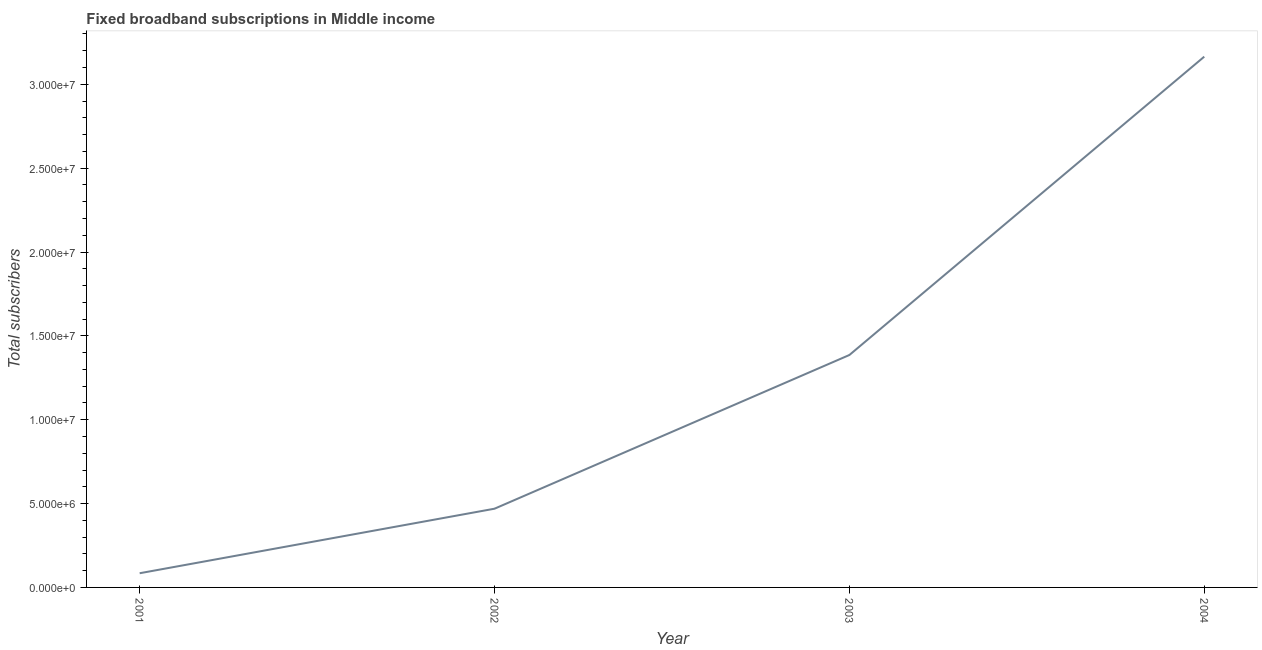What is the total number of fixed broadband subscriptions in 2001?
Offer a terse response. 8.47e+05. Across all years, what is the maximum total number of fixed broadband subscriptions?
Ensure brevity in your answer.  3.16e+07. Across all years, what is the minimum total number of fixed broadband subscriptions?
Keep it short and to the point. 8.47e+05. In which year was the total number of fixed broadband subscriptions maximum?
Provide a short and direct response. 2004. In which year was the total number of fixed broadband subscriptions minimum?
Your answer should be compact. 2001. What is the sum of the total number of fixed broadband subscriptions?
Your answer should be compact. 5.10e+07. What is the difference between the total number of fixed broadband subscriptions in 2001 and 2004?
Make the answer very short. -3.08e+07. What is the average total number of fixed broadband subscriptions per year?
Your response must be concise. 1.28e+07. What is the median total number of fixed broadband subscriptions?
Provide a succinct answer. 9.28e+06. In how many years, is the total number of fixed broadband subscriptions greater than 22000000 ?
Offer a terse response. 1. Do a majority of the years between 2001 and 2002 (inclusive) have total number of fixed broadband subscriptions greater than 25000000 ?
Your response must be concise. No. What is the ratio of the total number of fixed broadband subscriptions in 2001 to that in 2003?
Keep it short and to the point. 0.06. Is the total number of fixed broadband subscriptions in 2001 less than that in 2004?
Give a very brief answer. Yes. What is the difference between the highest and the second highest total number of fixed broadband subscriptions?
Offer a terse response. 1.78e+07. Is the sum of the total number of fixed broadband subscriptions in 2001 and 2004 greater than the maximum total number of fixed broadband subscriptions across all years?
Provide a short and direct response. Yes. What is the difference between the highest and the lowest total number of fixed broadband subscriptions?
Provide a short and direct response. 3.08e+07. How many lines are there?
Make the answer very short. 1. Are the values on the major ticks of Y-axis written in scientific E-notation?
Offer a terse response. Yes. Does the graph contain any zero values?
Keep it short and to the point. No. Does the graph contain grids?
Offer a very short reply. No. What is the title of the graph?
Provide a short and direct response. Fixed broadband subscriptions in Middle income. What is the label or title of the X-axis?
Your answer should be compact. Year. What is the label or title of the Y-axis?
Offer a terse response. Total subscribers. What is the Total subscribers in 2001?
Your answer should be compact. 8.47e+05. What is the Total subscribers in 2002?
Provide a succinct answer. 4.69e+06. What is the Total subscribers of 2003?
Your answer should be very brief. 1.39e+07. What is the Total subscribers in 2004?
Make the answer very short. 3.16e+07. What is the difference between the Total subscribers in 2001 and 2002?
Your answer should be very brief. -3.85e+06. What is the difference between the Total subscribers in 2001 and 2003?
Provide a short and direct response. -1.30e+07. What is the difference between the Total subscribers in 2001 and 2004?
Offer a very short reply. -3.08e+07. What is the difference between the Total subscribers in 2002 and 2003?
Provide a short and direct response. -9.16e+06. What is the difference between the Total subscribers in 2002 and 2004?
Your answer should be compact. -2.70e+07. What is the difference between the Total subscribers in 2003 and 2004?
Keep it short and to the point. -1.78e+07. What is the ratio of the Total subscribers in 2001 to that in 2002?
Your answer should be compact. 0.18. What is the ratio of the Total subscribers in 2001 to that in 2003?
Your response must be concise. 0.06. What is the ratio of the Total subscribers in 2001 to that in 2004?
Your response must be concise. 0.03. What is the ratio of the Total subscribers in 2002 to that in 2003?
Ensure brevity in your answer.  0.34. What is the ratio of the Total subscribers in 2002 to that in 2004?
Make the answer very short. 0.15. What is the ratio of the Total subscribers in 2003 to that in 2004?
Offer a very short reply. 0.44. 